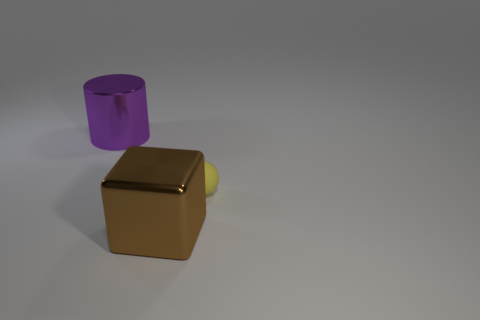What time of day does the lighting in this image suggest? The shadows and lighting in the image are soft and diffuse, lacking strong directional shadows that sunlight would create. This suggests an indoor setting or a cloudy day where light is scattered, making it difficult to ascertain the exact time of day from the lighting alone. 